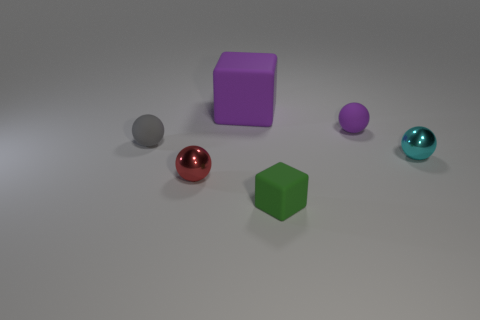What shape is the other matte thing that is the same color as the big rubber thing?
Give a very brief answer. Sphere. What number of things are on the left side of the cyan metal ball and in front of the large thing?
Your answer should be compact. 4. What is the red thing made of?
Provide a succinct answer. Metal. There is a purple matte object that is the same size as the gray sphere; what shape is it?
Your response must be concise. Sphere. Is the tiny gray thing in front of the tiny purple rubber thing made of the same material as the sphere behind the gray sphere?
Keep it short and to the point. Yes. How many yellow rubber objects are there?
Your answer should be very brief. 0. What number of tiny matte things have the same shape as the red metallic object?
Offer a very short reply. 2. Does the big purple rubber thing have the same shape as the gray matte object?
Provide a short and direct response. No. How big is the red shiny thing?
Your answer should be very brief. Small. What number of red spheres are the same size as the green object?
Provide a short and direct response. 1. 